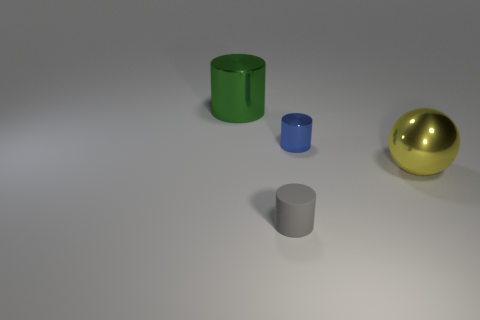Are there any other things that are the same material as the gray cylinder?
Your answer should be compact. No. There is a green object that is the same size as the yellow object; what is it made of?
Provide a succinct answer. Metal. What number of other things are made of the same material as the yellow sphere?
Your response must be concise. 2. What shape is the small object left of the cylinder to the right of the small gray matte object?
Offer a terse response. Cylinder. What number of objects are tiny gray rubber cylinders or big shiny cylinders that are to the left of the yellow sphere?
Provide a succinct answer. 2. How many other objects are there of the same color as the sphere?
Your answer should be compact. 0. What number of blue objects are large spheres or big shiny cylinders?
Provide a succinct answer. 0. There is a small cylinder that is in front of the big thing right of the small metal cylinder; are there any large yellow metallic spheres that are behind it?
Give a very brief answer. Yes. Are there any other things that are the same size as the green metallic cylinder?
Your response must be concise. Yes. Is the color of the shiny ball the same as the big cylinder?
Provide a succinct answer. No. 